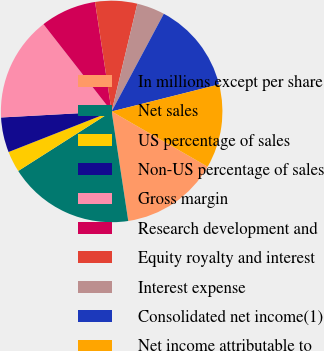Convert chart to OTSL. <chart><loc_0><loc_0><loc_500><loc_500><pie_chart><fcel>In millions except per share<fcel>Net sales<fcel>US percentage of sales<fcel>Non-US percentage of sales<fcel>Gross margin<fcel>Research development and<fcel>Equity royalty and interest<fcel>Interest expense<fcel>Consolidated net income(1)<fcel>Net income attributable to<nl><fcel>14.29%<fcel>18.37%<fcel>3.06%<fcel>5.1%<fcel>15.31%<fcel>8.16%<fcel>6.12%<fcel>4.08%<fcel>13.27%<fcel>12.24%<nl></chart> 